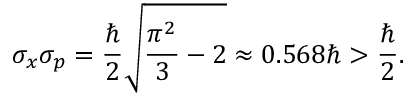Convert formula to latex. <formula><loc_0><loc_0><loc_500><loc_500>\sigma _ { x } \sigma _ { p } = { \frac { } { 2 } } { \sqrt { { \frac { \pi ^ { 2 } } { 3 } } - 2 } } \approx 0 . 5 6 8 \hbar { > } { \frac { } { 2 } } .</formula> 